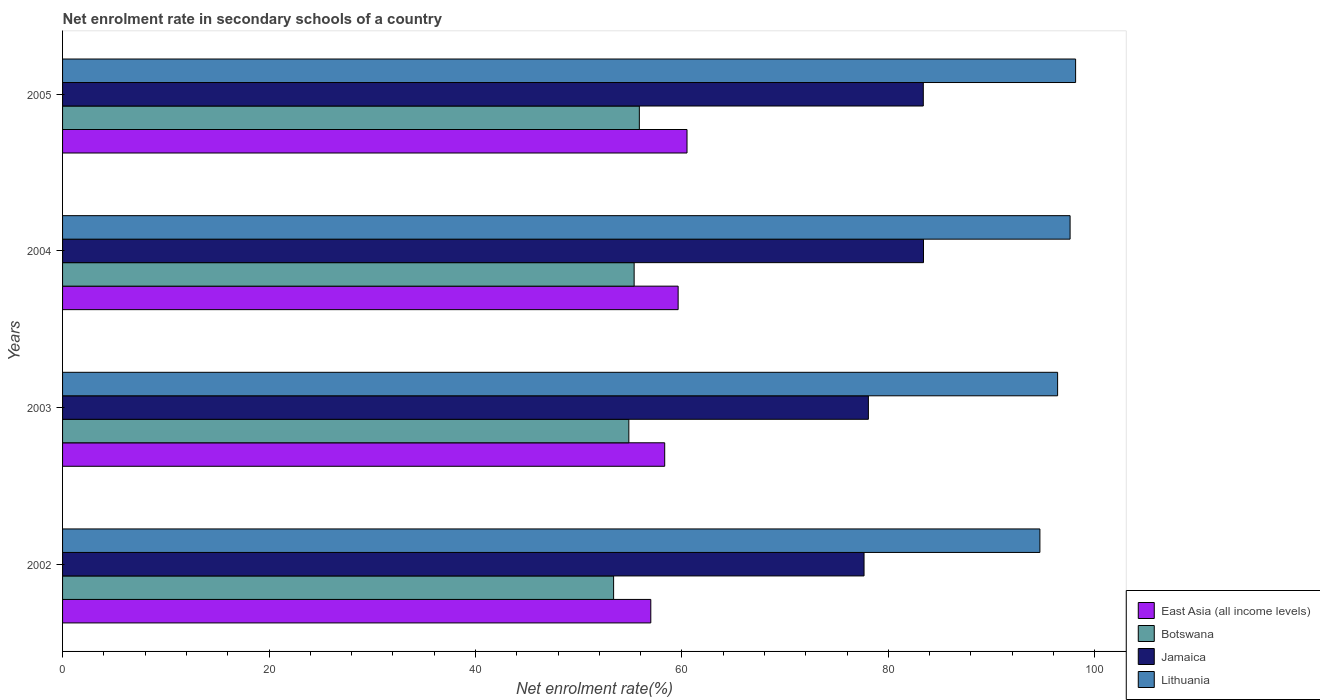How many different coloured bars are there?
Your answer should be very brief. 4. How many groups of bars are there?
Your answer should be compact. 4. How many bars are there on the 4th tick from the top?
Your answer should be compact. 4. How many bars are there on the 1st tick from the bottom?
Offer a terse response. 4. In how many cases, is the number of bars for a given year not equal to the number of legend labels?
Keep it short and to the point. 0. What is the net enrolment rate in secondary schools in Jamaica in 2005?
Your answer should be very brief. 83.39. Across all years, what is the maximum net enrolment rate in secondary schools in East Asia (all income levels)?
Ensure brevity in your answer.  60.5. Across all years, what is the minimum net enrolment rate in secondary schools in Botswana?
Offer a terse response. 53.39. What is the total net enrolment rate in secondary schools in Botswana in the graph?
Your answer should be compact. 219.51. What is the difference between the net enrolment rate in secondary schools in Botswana in 2003 and that in 2004?
Offer a very short reply. -0.51. What is the difference between the net enrolment rate in secondary schools in East Asia (all income levels) in 2004 and the net enrolment rate in secondary schools in Lithuania in 2005?
Offer a very short reply. -38.51. What is the average net enrolment rate in secondary schools in Botswana per year?
Make the answer very short. 54.88. In the year 2005, what is the difference between the net enrolment rate in secondary schools in Jamaica and net enrolment rate in secondary schools in East Asia (all income levels)?
Provide a succinct answer. 22.89. What is the ratio of the net enrolment rate in secondary schools in Lithuania in 2002 to that in 2003?
Your response must be concise. 0.98. What is the difference between the highest and the second highest net enrolment rate in secondary schools in East Asia (all income levels)?
Offer a very short reply. 0.86. What is the difference between the highest and the lowest net enrolment rate in secondary schools in Botswana?
Keep it short and to the point. 2.49. In how many years, is the net enrolment rate in secondary schools in Botswana greater than the average net enrolment rate in secondary schools in Botswana taken over all years?
Your response must be concise. 2. Is the sum of the net enrolment rate in secondary schools in Lithuania in 2004 and 2005 greater than the maximum net enrolment rate in secondary schools in Jamaica across all years?
Keep it short and to the point. Yes. Is it the case that in every year, the sum of the net enrolment rate in secondary schools in Lithuania and net enrolment rate in secondary schools in Botswana is greater than the sum of net enrolment rate in secondary schools in Jamaica and net enrolment rate in secondary schools in East Asia (all income levels)?
Your answer should be compact. Yes. What does the 3rd bar from the top in 2002 represents?
Offer a terse response. Botswana. What does the 3rd bar from the bottom in 2003 represents?
Offer a terse response. Jamaica. Is it the case that in every year, the sum of the net enrolment rate in secondary schools in East Asia (all income levels) and net enrolment rate in secondary schools in Lithuania is greater than the net enrolment rate in secondary schools in Jamaica?
Your answer should be compact. Yes. How many bars are there?
Make the answer very short. 16. Are all the bars in the graph horizontal?
Your answer should be very brief. Yes. What is the difference between two consecutive major ticks on the X-axis?
Ensure brevity in your answer.  20. Are the values on the major ticks of X-axis written in scientific E-notation?
Make the answer very short. No. Does the graph contain grids?
Make the answer very short. No. Where does the legend appear in the graph?
Give a very brief answer. Bottom right. How many legend labels are there?
Give a very brief answer. 4. What is the title of the graph?
Provide a succinct answer. Net enrolment rate in secondary schools of a country. What is the label or title of the X-axis?
Keep it short and to the point. Net enrolment rate(%). What is the label or title of the Y-axis?
Make the answer very short. Years. What is the Net enrolment rate(%) in East Asia (all income levels) in 2002?
Your answer should be compact. 56.99. What is the Net enrolment rate(%) of Botswana in 2002?
Provide a succinct answer. 53.39. What is the Net enrolment rate(%) in Jamaica in 2002?
Your response must be concise. 77.65. What is the Net enrolment rate(%) of Lithuania in 2002?
Give a very brief answer. 94.69. What is the Net enrolment rate(%) of East Asia (all income levels) in 2003?
Keep it short and to the point. 58.34. What is the Net enrolment rate(%) in Botswana in 2003?
Your response must be concise. 54.86. What is the Net enrolment rate(%) in Jamaica in 2003?
Keep it short and to the point. 78.07. What is the Net enrolment rate(%) of Lithuania in 2003?
Give a very brief answer. 96.41. What is the Net enrolment rate(%) of East Asia (all income levels) in 2004?
Your answer should be very brief. 59.64. What is the Net enrolment rate(%) of Botswana in 2004?
Ensure brevity in your answer.  55.38. What is the Net enrolment rate(%) of Jamaica in 2004?
Make the answer very short. 83.41. What is the Net enrolment rate(%) in Lithuania in 2004?
Offer a very short reply. 97.61. What is the Net enrolment rate(%) of East Asia (all income levels) in 2005?
Provide a succinct answer. 60.5. What is the Net enrolment rate(%) of Botswana in 2005?
Offer a very short reply. 55.88. What is the Net enrolment rate(%) of Jamaica in 2005?
Offer a terse response. 83.39. What is the Net enrolment rate(%) in Lithuania in 2005?
Your answer should be very brief. 98.15. Across all years, what is the maximum Net enrolment rate(%) of East Asia (all income levels)?
Keep it short and to the point. 60.5. Across all years, what is the maximum Net enrolment rate(%) of Botswana?
Offer a very short reply. 55.88. Across all years, what is the maximum Net enrolment rate(%) of Jamaica?
Your answer should be very brief. 83.41. Across all years, what is the maximum Net enrolment rate(%) of Lithuania?
Your response must be concise. 98.15. Across all years, what is the minimum Net enrolment rate(%) in East Asia (all income levels)?
Keep it short and to the point. 56.99. Across all years, what is the minimum Net enrolment rate(%) in Botswana?
Keep it short and to the point. 53.39. Across all years, what is the minimum Net enrolment rate(%) in Jamaica?
Give a very brief answer. 77.65. Across all years, what is the minimum Net enrolment rate(%) of Lithuania?
Your response must be concise. 94.69. What is the total Net enrolment rate(%) in East Asia (all income levels) in the graph?
Offer a very short reply. 235.47. What is the total Net enrolment rate(%) of Botswana in the graph?
Provide a short and direct response. 219.51. What is the total Net enrolment rate(%) of Jamaica in the graph?
Your answer should be very brief. 322.53. What is the total Net enrolment rate(%) in Lithuania in the graph?
Provide a short and direct response. 386.86. What is the difference between the Net enrolment rate(%) of East Asia (all income levels) in 2002 and that in 2003?
Give a very brief answer. -1.35. What is the difference between the Net enrolment rate(%) in Botswana in 2002 and that in 2003?
Keep it short and to the point. -1.48. What is the difference between the Net enrolment rate(%) in Jamaica in 2002 and that in 2003?
Offer a terse response. -0.42. What is the difference between the Net enrolment rate(%) in Lithuania in 2002 and that in 2003?
Make the answer very short. -1.72. What is the difference between the Net enrolment rate(%) of East Asia (all income levels) in 2002 and that in 2004?
Offer a terse response. -2.65. What is the difference between the Net enrolment rate(%) of Botswana in 2002 and that in 2004?
Offer a terse response. -1.99. What is the difference between the Net enrolment rate(%) of Jamaica in 2002 and that in 2004?
Ensure brevity in your answer.  -5.76. What is the difference between the Net enrolment rate(%) of Lithuania in 2002 and that in 2004?
Provide a short and direct response. -2.93. What is the difference between the Net enrolment rate(%) in East Asia (all income levels) in 2002 and that in 2005?
Offer a terse response. -3.51. What is the difference between the Net enrolment rate(%) in Botswana in 2002 and that in 2005?
Offer a terse response. -2.49. What is the difference between the Net enrolment rate(%) of Jamaica in 2002 and that in 2005?
Give a very brief answer. -5.74. What is the difference between the Net enrolment rate(%) in Lithuania in 2002 and that in 2005?
Give a very brief answer. -3.46. What is the difference between the Net enrolment rate(%) in East Asia (all income levels) in 2003 and that in 2004?
Your answer should be very brief. -1.3. What is the difference between the Net enrolment rate(%) in Botswana in 2003 and that in 2004?
Make the answer very short. -0.51. What is the difference between the Net enrolment rate(%) of Jamaica in 2003 and that in 2004?
Provide a short and direct response. -5.34. What is the difference between the Net enrolment rate(%) in Lithuania in 2003 and that in 2004?
Your response must be concise. -1.21. What is the difference between the Net enrolment rate(%) in East Asia (all income levels) in 2003 and that in 2005?
Your response must be concise. -2.16. What is the difference between the Net enrolment rate(%) of Botswana in 2003 and that in 2005?
Provide a succinct answer. -1.02. What is the difference between the Net enrolment rate(%) in Jamaica in 2003 and that in 2005?
Offer a terse response. -5.32. What is the difference between the Net enrolment rate(%) of Lithuania in 2003 and that in 2005?
Ensure brevity in your answer.  -1.74. What is the difference between the Net enrolment rate(%) in East Asia (all income levels) in 2004 and that in 2005?
Provide a short and direct response. -0.86. What is the difference between the Net enrolment rate(%) in Botswana in 2004 and that in 2005?
Offer a terse response. -0.5. What is the difference between the Net enrolment rate(%) of Jamaica in 2004 and that in 2005?
Your answer should be very brief. 0.02. What is the difference between the Net enrolment rate(%) in Lithuania in 2004 and that in 2005?
Ensure brevity in your answer.  -0.53. What is the difference between the Net enrolment rate(%) in East Asia (all income levels) in 2002 and the Net enrolment rate(%) in Botswana in 2003?
Offer a very short reply. 2.13. What is the difference between the Net enrolment rate(%) in East Asia (all income levels) in 2002 and the Net enrolment rate(%) in Jamaica in 2003?
Your response must be concise. -21.08. What is the difference between the Net enrolment rate(%) in East Asia (all income levels) in 2002 and the Net enrolment rate(%) in Lithuania in 2003?
Your answer should be compact. -39.41. What is the difference between the Net enrolment rate(%) in Botswana in 2002 and the Net enrolment rate(%) in Jamaica in 2003?
Make the answer very short. -24.68. What is the difference between the Net enrolment rate(%) in Botswana in 2002 and the Net enrolment rate(%) in Lithuania in 2003?
Keep it short and to the point. -43.02. What is the difference between the Net enrolment rate(%) in Jamaica in 2002 and the Net enrolment rate(%) in Lithuania in 2003?
Provide a succinct answer. -18.75. What is the difference between the Net enrolment rate(%) in East Asia (all income levels) in 2002 and the Net enrolment rate(%) in Botswana in 2004?
Keep it short and to the point. 1.61. What is the difference between the Net enrolment rate(%) in East Asia (all income levels) in 2002 and the Net enrolment rate(%) in Jamaica in 2004?
Give a very brief answer. -26.42. What is the difference between the Net enrolment rate(%) of East Asia (all income levels) in 2002 and the Net enrolment rate(%) of Lithuania in 2004?
Your response must be concise. -40.62. What is the difference between the Net enrolment rate(%) in Botswana in 2002 and the Net enrolment rate(%) in Jamaica in 2004?
Your answer should be very brief. -30.02. What is the difference between the Net enrolment rate(%) in Botswana in 2002 and the Net enrolment rate(%) in Lithuania in 2004?
Make the answer very short. -44.23. What is the difference between the Net enrolment rate(%) in Jamaica in 2002 and the Net enrolment rate(%) in Lithuania in 2004?
Provide a succinct answer. -19.96. What is the difference between the Net enrolment rate(%) of East Asia (all income levels) in 2002 and the Net enrolment rate(%) of Botswana in 2005?
Provide a short and direct response. 1.11. What is the difference between the Net enrolment rate(%) of East Asia (all income levels) in 2002 and the Net enrolment rate(%) of Jamaica in 2005?
Give a very brief answer. -26.4. What is the difference between the Net enrolment rate(%) in East Asia (all income levels) in 2002 and the Net enrolment rate(%) in Lithuania in 2005?
Your response must be concise. -41.16. What is the difference between the Net enrolment rate(%) of Botswana in 2002 and the Net enrolment rate(%) of Jamaica in 2005?
Make the answer very short. -30. What is the difference between the Net enrolment rate(%) in Botswana in 2002 and the Net enrolment rate(%) in Lithuania in 2005?
Provide a succinct answer. -44.76. What is the difference between the Net enrolment rate(%) in Jamaica in 2002 and the Net enrolment rate(%) in Lithuania in 2005?
Your response must be concise. -20.5. What is the difference between the Net enrolment rate(%) of East Asia (all income levels) in 2003 and the Net enrolment rate(%) of Botswana in 2004?
Provide a short and direct response. 2.96. What is the difference between the Net enrolment rate(%) in East Asia (all income levels) in 2003 and the Net enrolment rate(%) in Jamaica in 2004?
Provide a succinct answer. -25.07. What is the difference between the Net enrolment rate(%) in East Asia (all income levels) in 2003 and the Net enrolment rate(%) in Lithuania in 2004?
Your answer should be compact. -39.28. What is the difference between the Net enrolment rate(%) in Botswana in 2003 and the Net enrolment rate(%) in Jamaica in 2004?
Your answer should be very brief. -28.55. What is the difference between the Net enrolment rate(%) in Botswana in 2003 and the Net enrolment rate(%) in Lithuania in 2004?
Provide a succinct answer. -42.75. What is the difference between the Net enrolment rate(%) in Jamaica in 2003 and the Net enrolment rate(%) in Lithuania in 2004?
Make the answer very short. -19.54. What is the difference between the Net enrolment rate(%) in East Asia (all income levels) in 2003 and the Net enrolment rate(%) in Botswana in 2005?
Keep it short and to the point. 2.46. What is the difference between the Net enrolment rate(%) of East Asia (all income levels) in 2003 and the Net enrolment rate(%) of Jamaica in 2005?
Provide a succinct answer. -25.05. What is the difference between the Net enrolment rate(%) of East Asia (all income levels) in 2003 and the Net enrolment rate(%) of Lithuania in 2005?
Offer a terse response. -39.81. What is the difference between the Net enrolment rate(%) in Botswana in 2003 and the Net enrolment rate(%) in Jamaica in 2005?
Offer a very short reply. -28.53. What is the difference between the Net enrolment rate(%) of Botswana in 2003 and the Net enrolment rate(%) of Lithuania in 2005?
Provide a short and direct response. -43.29. What is the difference between the Net enrolment rate(%) of Jamaica in 2003 and the Net enrolment rate(%) of Lithuania in 2005?
Your answer should be very brief. -20.08. What is the difference between the Net enrolment rate(%) in East Asia (all income levels) in 2004 and the Net enrolment rate(%) in Botswana in 2005?
Offer a terse response. 3.76. What is the difference between the Net enrolment rate(%) of East Asia (all income levels) in 2004 and the Net enrolment rate(%) of Jamaica in 2005?
Give a very brief answer. -23.75. What is the difference between the Net enrolment rate(%) of East Asia (all income levels) in 2004 and the Net enrolment rate(%) of Lithuania in 2005?
Offer a very short reply. -38.51. What is the difference between the Net enrolment rate(%) in Botswana in 2004 and the Net enrolment rate(%) in Jamaica in 2005?
Ensure brevity in your answer.  -28.01. What is the difference between the Net enrolment rate(%) of Botswana in 2004 and the Net enrolment rate(%) of Lithuania in 2005?
Your answer should be very brief. -42.77. What is the difference between the Net enrolment rate(%) in Jamaica in 2004 and the Net enrolment rate(%) in Lithuania in 2005?
Ensure brevity in your answer.  -14.74. What is the average Net enrolment rate(%) in East Asia (all income levels) per year?
Give a very brief answer. 58.87. What is the average Net enrolment rate(%) of Botswana per year?
Ensure brevity in your answer.  54.88. What is the average Net enrolment rate(%) in Jamaica per year?
Offer a terse response. 80.63. What is the average Net enrolment rate(%) in Lithuania per year?
Keep it short and to the point. 96.71. In the year 2002, what is the difference between the Net enrolment rate(%) of East Asia (all income levels) and Net enrolment rate(%) of Botswana?
Make the answer very short. 3.6. In the year 2002, what is the difference between the Net enrolment rate(%) of East Asia (all income levels) and Net enrolment rate(%) of Jamaica?
Your answer should be compact. -20.66. In the year 2002, what is the difference between the Net enrolment rate(%) in East Asia (all income levels) and Net enrolment rate(%) in Lithuania?
Offer a terse response. -37.7. In the year 2002, what is the difference between the Net enrolment rate(%) in Botswana and Net enrolment rate(%) in Jamaica?
Your answer should be compact. -24.26. In the year 2002, what is the difference between the Net enrolment rate(%) in Botswana and Net enrolment rate(%) in Lithuania?
Your answer should be compact. -41.3. In the year 2002, what is the difference between the Net enrolment rate(%) in Jamaica and Net enrolment rate(%) in Lithuania?
Ensure brevity in your answer.  -17.04. In the year 2003, what is the difference between the Net enrolment rate(%) of East Asia (all income levels) and Net enrolment rate(%) of Botswana?
Give a very brief answer. 3.47. In the year 2003, what is the difference between the Net enrolment rate(%) of East Asia (all income levels) and Net enrolment rate(%) of Jamaica?
Provide a succinct answer. -19.73. In the year 2003, what is the difference between the Net enrolment rate(%) in East Asia (all income levels) and Net enrolment rate(%) in Lithuania?
Keep it short and to the point. -38.07. In the year 2003, what is the difference between the Net enrolment rate(%) of Botswana and Net enrolment rate(%) of Jamaica?
Your answer should be compact. -23.21. In the year 2003, what is the difference between the Net enrolment rate(%) of Botswana and Net enrolment rate(%) of Lithuania?
Offer a very short reply. -41.54. In the year 2003, what is the difference between the Net enrolment rate(%) of Jamaica and Net enrolment rate(%) of Lithuania?
Keep it short and to the point. -18.33. In the year 2004, what is the difference between the Net enrolment rate(%) in East Asia (all income levels) and Net enrolment rate(%) in Botswana?
Ensure brevity in your answer.  4.26. In the year 2004, what is the difference between the Net enrolment rate(%) in East Asia (all income levels) and Net enrolment rate(%) in Jamaica?
Your answer should be very brief. -23.77. In the year 2004, what is the difference between the Net enrolment rate(%) in East Asia (all income levels) and Net enrolment rate(%) in Lithuania?
Give a very brief answer. -37.97. In the year 2004, what is the difference between the Net enrolment rate(%) of Botswana and Net enrolment rate(%) of Jamaica?
Your response must be concise. -28.03. In the year 2004, what is the difference between the Net enrolment rate(%) in Botswana and Net enrolment rate(%) in Lithuania?
Provide a short and direct response. -42.24. In the year 2004, what is the difference between the Net enrolment rate(%) of Jamaica and Net enrolment rate(%) of Lithuania?
Keep it short and to the point. -14.2. In the year 2005, what is the difference between the Net enrolment rate(%) of East Asia (all income levels) and Net enrolment rate(%) of Botswana?
Make the answer very short. 4.62. In the year 2005, what is the difference between the Net enrolment rate(%) of East Asia (all income levels) and Net enrolment rate(%) of Jamaica?
Your response must be concise. -22.89. In the year 2005, what is the difference between the Net enrolment rate(%) in East Asia (all income levels) and Net enrolment rate(%) in Lithuania?
Your answer should be compact. -37.65. In the year 2005, what is the difference between the Net enrolment rate(%) in Botswana and Net enrolment rate(%) in Jamaica?
Provide a succinct answer. -27.51. In the year 2005, what is the difference between the Net enrolment rate(%) of Botswana and Net enrolment rate(%) of Lithuania?
Keep it short and to the point. -42.27. In the year 2005, what is the difference between the Net enrolment rate(%) of Jamaica and Net enrolment rate(%) of Lithuania?
Your response must be concise. -14.76. What is the ratio of the Net enrolment rate(%) of East Asia (all income levels) in 2002 to that in 2003?
Keep it short and to the point. 0.98. What is the ratio of the Net enrolment rate(%) in Botswana in 2002 to that in 2003?
Offer a terse response. 0.97. What is the ratio of the Net enrolment rate(%) of Lithuania in 2002 to that in 2003?
Give a very brief answer. 0.98. What is the ratio of the Net enrolment rate(%) in East Asia (all income levels) in 2002 to that in 2004?
Your response must be concise. 0.96. What is the ratio of the Net enrolment rate(%) in Botswana in 2002 to that in 2004?
Offer a very short reply. 0.96. What is the ratio of the Net enrolment rate(%) of Jamaica in 2002 to that in 2004?
Ensure brevity in your answer.  0.93. What is the ratio of the Net enrolment rate(%) of Lithuania in 2002 to that in 2004?
Keep it short and to the point. 0.97. What is the ratio of the Net enrolment rate(%) in East Asia (all income levels) in 2002 to that in 2005?
Offer a very short reply. 0.94. What is the ratio of the Net enrolment rate(%) in Botswana in 2002 to that in 2005?
Provide a succinct answer. 0.96. What is the ratio of the Net enrolment rate(%) in Jamaica in 2002 to that in 2005?
Your answer should be compact. 0.93. What is the ratio of the Net enrolment rate(%) of Lithuania in 2002 to that in 2005?
Keep it short and to the point. 0.96. What is the ratio of the Net enrolment rate(%) in East Asia (all income levels) in 2003 to that in 2004?
Your answer should be very brief. 0.98. What is the ratio of the Net enrolment rate(%) in Botswana in 2003 to that in 2004?
Ensure brevity in your answer.  0.99. What is the ratio of the Net enrolment rate(%) of Jamaica in 2003 to that in 2004?
Make the answer very short. 0.94. What is the ratio of the Net enrolment rate(%) in Lithuania in 2003 to that in 2004?
Ensure brevity in your answer.  0.99. What is the ratio of the Net enrolment rate(%) in East Asia (all income levels) in 2003 to that in 2005?
Provide a succinct answer. 0.96. What is the ratio of the Net enrolment rate(%) of Botswana in 2003 to that in 2005?
Provide a succinct answer. 0.98. What is the ratio of the Net enrolment rate(%) of Jamaica in 2003 to that in 2005?
Your answer should be very brief. 0.94. What is the ratio of the Net enrolment rate(%) of Lithuania in 2003 to that in 2005?
Your response must be concise. 0.98. What is the ratio of the Net enrolment rate(%) of East Asia (all income levels) in 2004 to that in 2005?
Offer a very short reply. 0.99. What is the ratio of the Net enrolment rate(%) in Jamaica in 2004 to that in 2005?
Offer a terse response. 1. What is the difference between the highest and the second highest Net enrolment rate(%) in East Asia (all income levels)?
Give a very brief answer. 0.86. What is the difference between the highest and the second highest Net enrolment rate(%) of Botswana?
Your answer should be very brief. 0.5. What is the difference between the highest and the second highest Net enrolment rate(%) of Jamaica?
Your answer should be compact. 0.02. What is the difference between the highest and the second highest Net enrolment rate(%) in Lithuania?
Provide a succinct answer. 0.53. What is the difference between the highest and the lowest Net enrolment rate(%) of East Asia (all income levels)?
Your answer should be compact. 3.51. What is the difference between the highest and the lowest Net enrolment rate(%) in Botswana?
Give a very brief answer. 2.49. What is the difference between the highest and the lowest Net enrolment rate(%) in Jamaica?
Your answer should be compact. 5.76. What is the difference between the highest and the lowest Net enrolment rate(%) of Lithuania?
Make the answer very short. 3.46. 